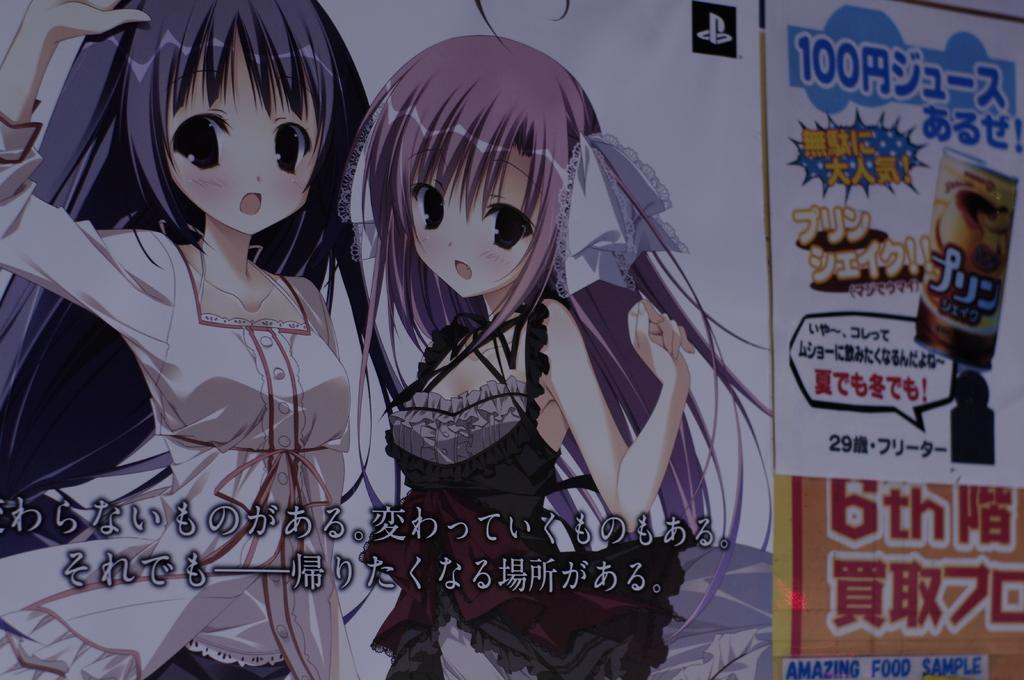What is present in the image that contains both images and text? There is a poster in the image that contains images and text. What type of food is being discussed on the poster in the image? There is no food or discussion present on the poster in the image; it only contains images and text. Can you see a cactus in the image? There is no cactus present in the image. 